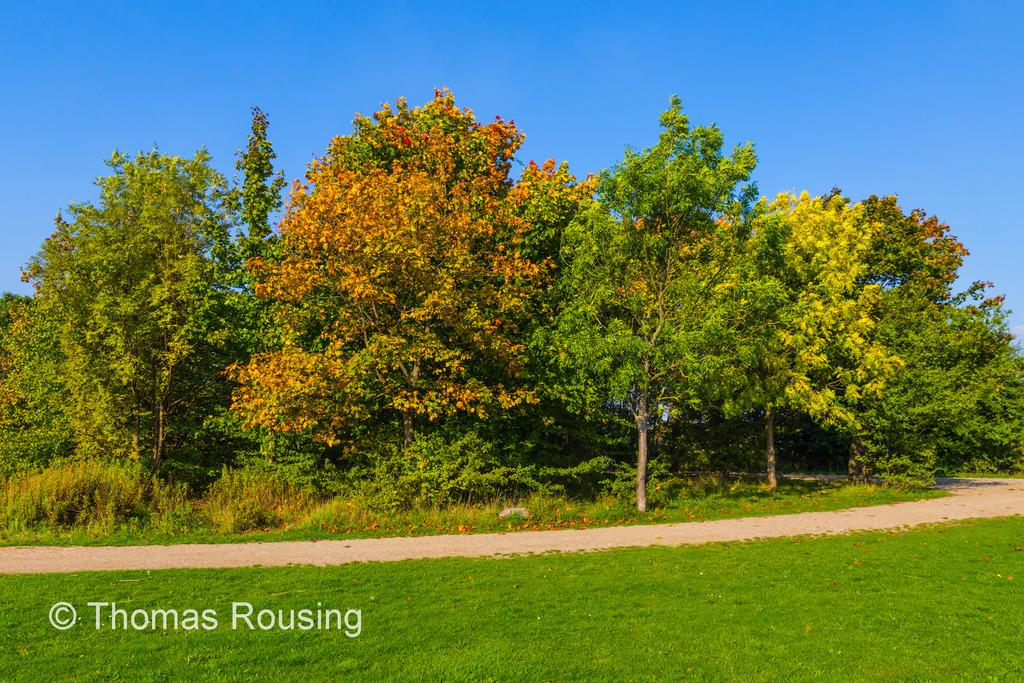What type of vegetation can be seen in the image? There are trees in the image. What is covering the ground in the image? There is grass on the ground in the image. What part of the natural environment is visible in the image? The sky is visible in the background of the image. What time is displayed on the clock in the image? There is no clock present in the image. 